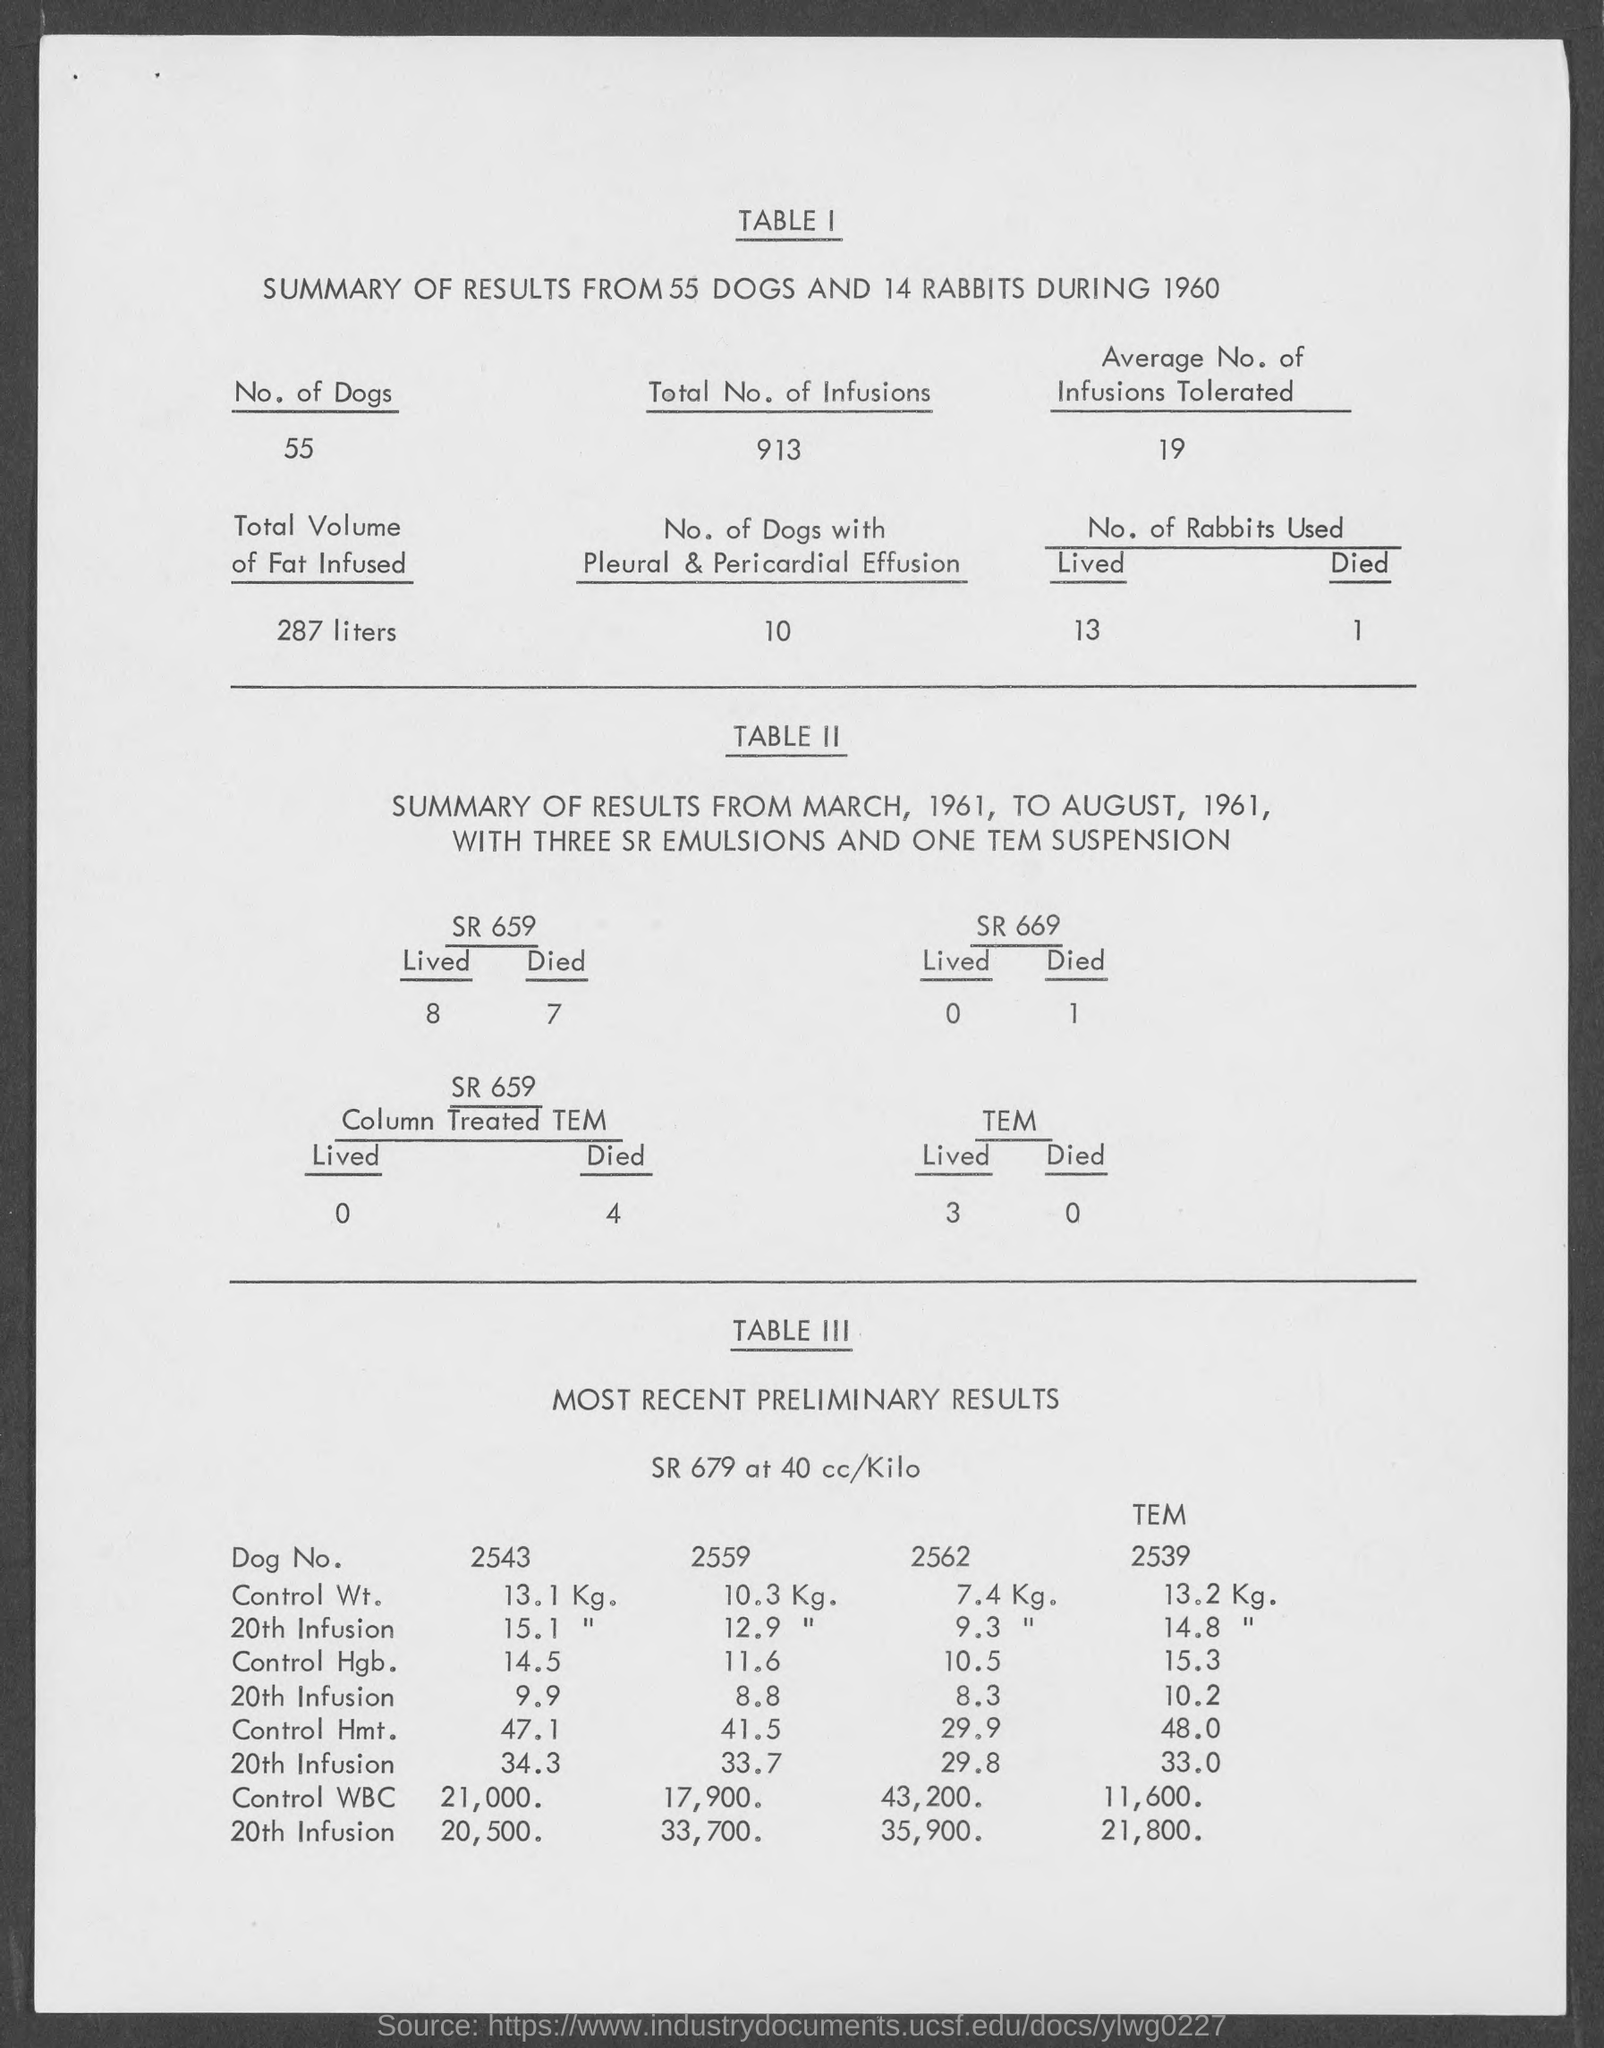What is the title of TABLE I given here?
Keep it short and to the point. SUMMARY OF RESULTS FROM 55 DOGS AND 14 RABBITS DURING 1960. What is the No. of dogs mentioned in TABLE 1?
Provide a succinct answer. 55. What is the total no. of Infusions mentioned in TABLE 1?
Provide a short and direct response. 913. What is the total volume of fat infused as given in TABLE I?
Provide a short and direct response. 287 liters. What is the No. of dogs with Pleural & Pericardial Effusion given in TABLE I?
Your answer should be compact. 10. What is the average No. of Infusions tolerated as given in TABLE 1?
Offer a very short reply. 19. 